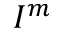Convert formula to latex. <formula><loc_0><loc_0><loc_500><loc_500>I ^ { m }</formula> 